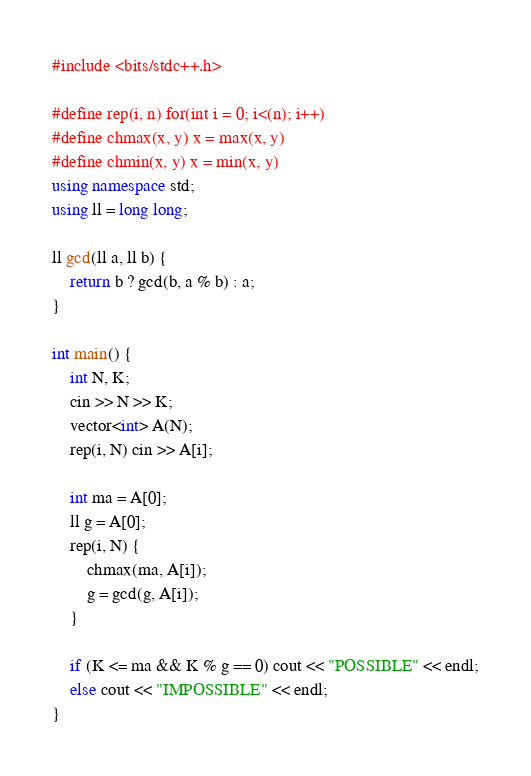Convert code to text. <code><loc_0><loc_0><loc_500><loc_500><_C++_>#include <bits/stdc++.h>

#define rep(i, n) for(int i = 0; i<(n); i++)
#define chmax(x, y) x = max(x, y)
#define chmin(x, y) x = min(x, y)
using namespace std;
using ll = long long;

ll gcd(ll a, ll b) {
    return b ? gcd(b, a % b) : a;
}

int main() {
    int N, K;
    cin >> N >> K;
    vector<int> A(N);
    rep(i, N) cin >> A[i];

    int ma = A[0];
    ll g = A[0];
    rep(i, N) {
        chmax(ma, A[i]);
        g = gcd(g, A[i]);
    }

    if (K <= ma && K % g == 0) cout << "POSSIBLE" << endl;
    else cout << "IMPOSSIBLE" << endl;
}</code> 